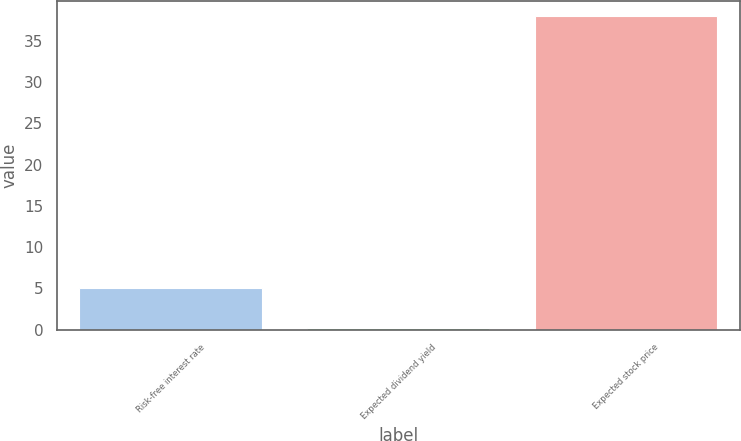Convert chart to OTSL. <chart><loc_0><loc_0><loc_500><loc_500><bar_chart><fcel>Risk-free interest rate<fcel>Expected dividend yield<fcel>Expected stock price<nl><fcel>4.99<fcel>0.15<fcel>38<nl></chart> 